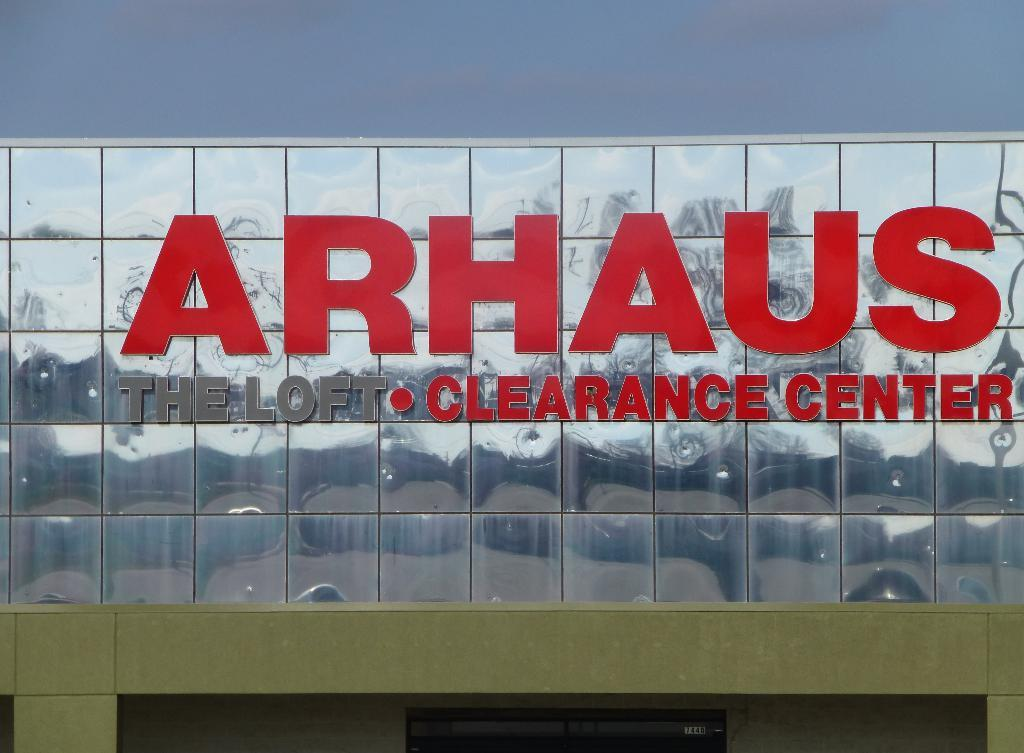<image>
Summarize the visual content of the image. A sign for Arhaus clearance center on a reflective background. 